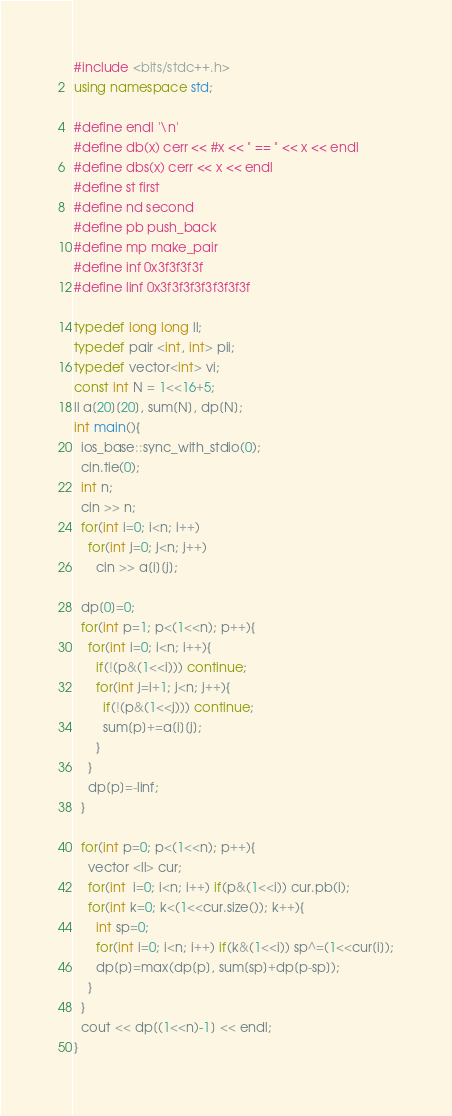<code> <loc_0><loc_0><loc_500><loc_500><_C++_>#include <bits/stdc++.h>
using namespace std;

#define endl '\n'
#define db(x) cerr << #x << " == " << x << endl
#define dbs(x) cerr << x << endl
#define st first
#define nd second
#define pb push_back
#define mp make_pair
#define inf 0x3f3f3f3f
#define linf 0x3f3f3f3f3f3f3f3f

typedef long long ll;
typedef pair <int, int> pii;
typedef vector<int> vi;
const int N = 1<<16+5;
ll a[20][20], sum[N], dp[N];
int main(){
  ios_base::sync_with_stdio(0);
  cin.tie(0);
  int n;
  cin >> n;
  for(int i=0; i<n; i++)
    for(int j=0; j<n; j++)
      cin >> a[i][j];

  dp[0]=0;
  for(int p=1; p<(1<<n); p++){
    for(int i=0; i<n; i++){
      if(!(p&(1<<i))) continue;
      for(int j=i+1; j<n; j++){
        if(!(p&(1<<j))) continue;
        sum[p]+=a[i][j];
      }
    }
    dp[p]=-linf;
  }

  for(int p=0; p<(1<<n); p++){
    vector <ll> cur;
    for(int  i=0; i<n; i++) if(p&(1<<i)) cur.pb(i);
    for(int k=0; k<(1<<cur.size()); k++){
      int sp=0;
      for(int i=0; i<n; i++) if(k&(1<<i)) sp^=(1<<cur[i]);
      dp[p]=max(dp[p], sum[sp]+dp[p-sp]);
    }
  }
  cout << dp[(1<<n)-1] << endl;
}</code> 